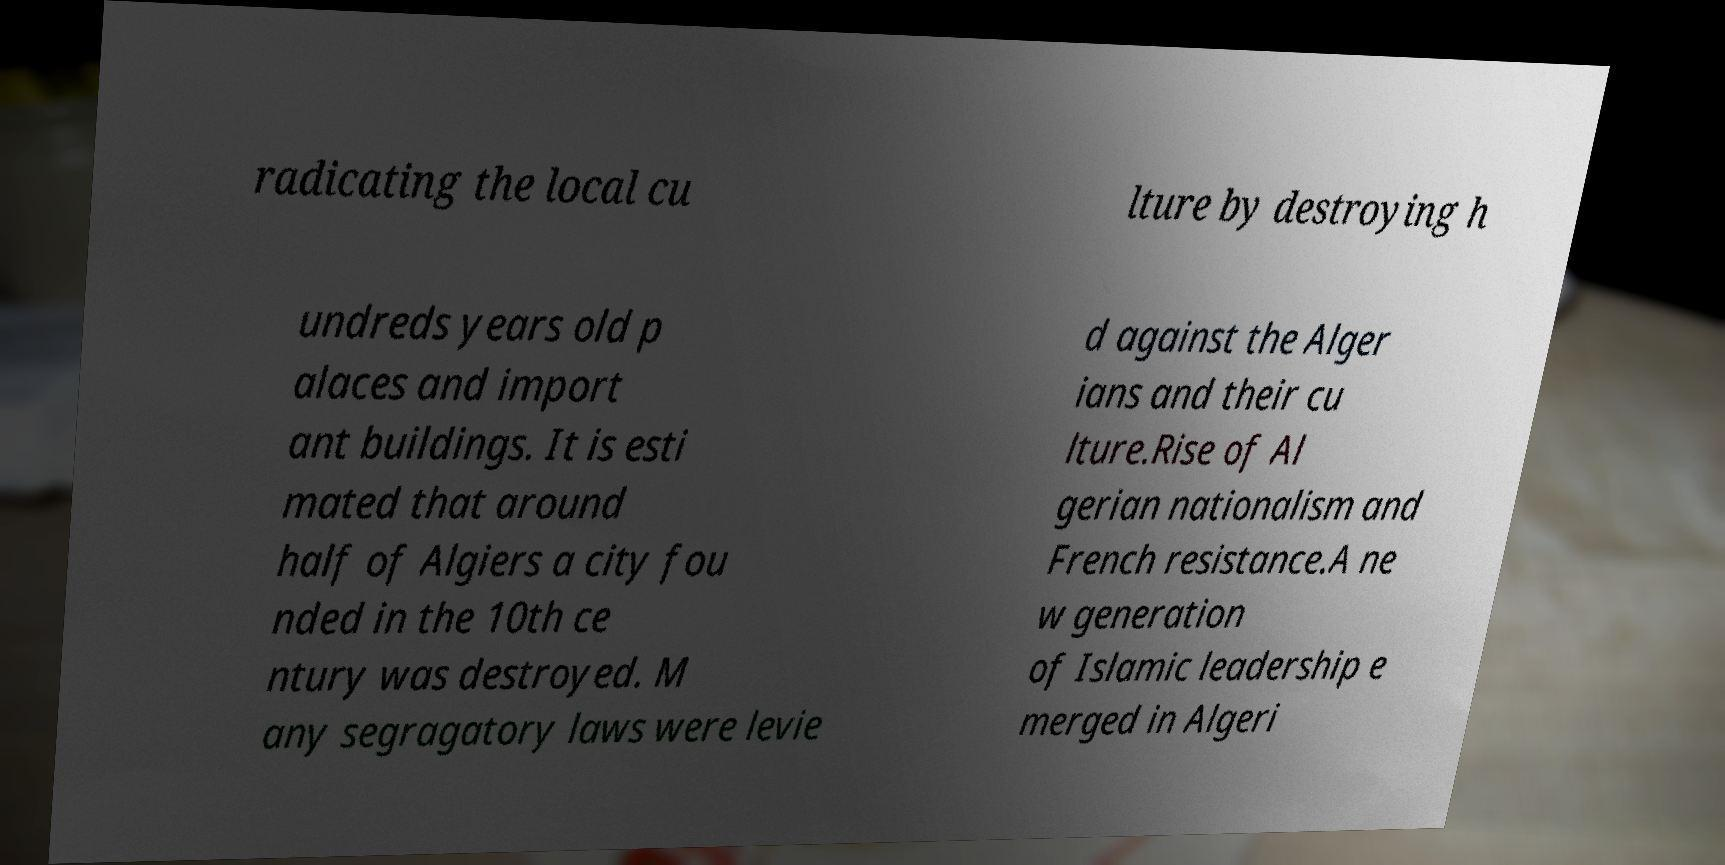For documentation purposes, I need the text within this image transcribed. Could you provide that? radicating the local cu lture by destroying h undreds years old p alaces and import ant buildings. It is esti mated that around half of Algiers a city fou nded in the 10th ce ntury was destroyed. M any segragatory laws were levie d against the Alger ians and their cu lture.Rise of Al gerian nationalism and French resistance.A ne w generation of Islamic leadership e merged in Algeri 